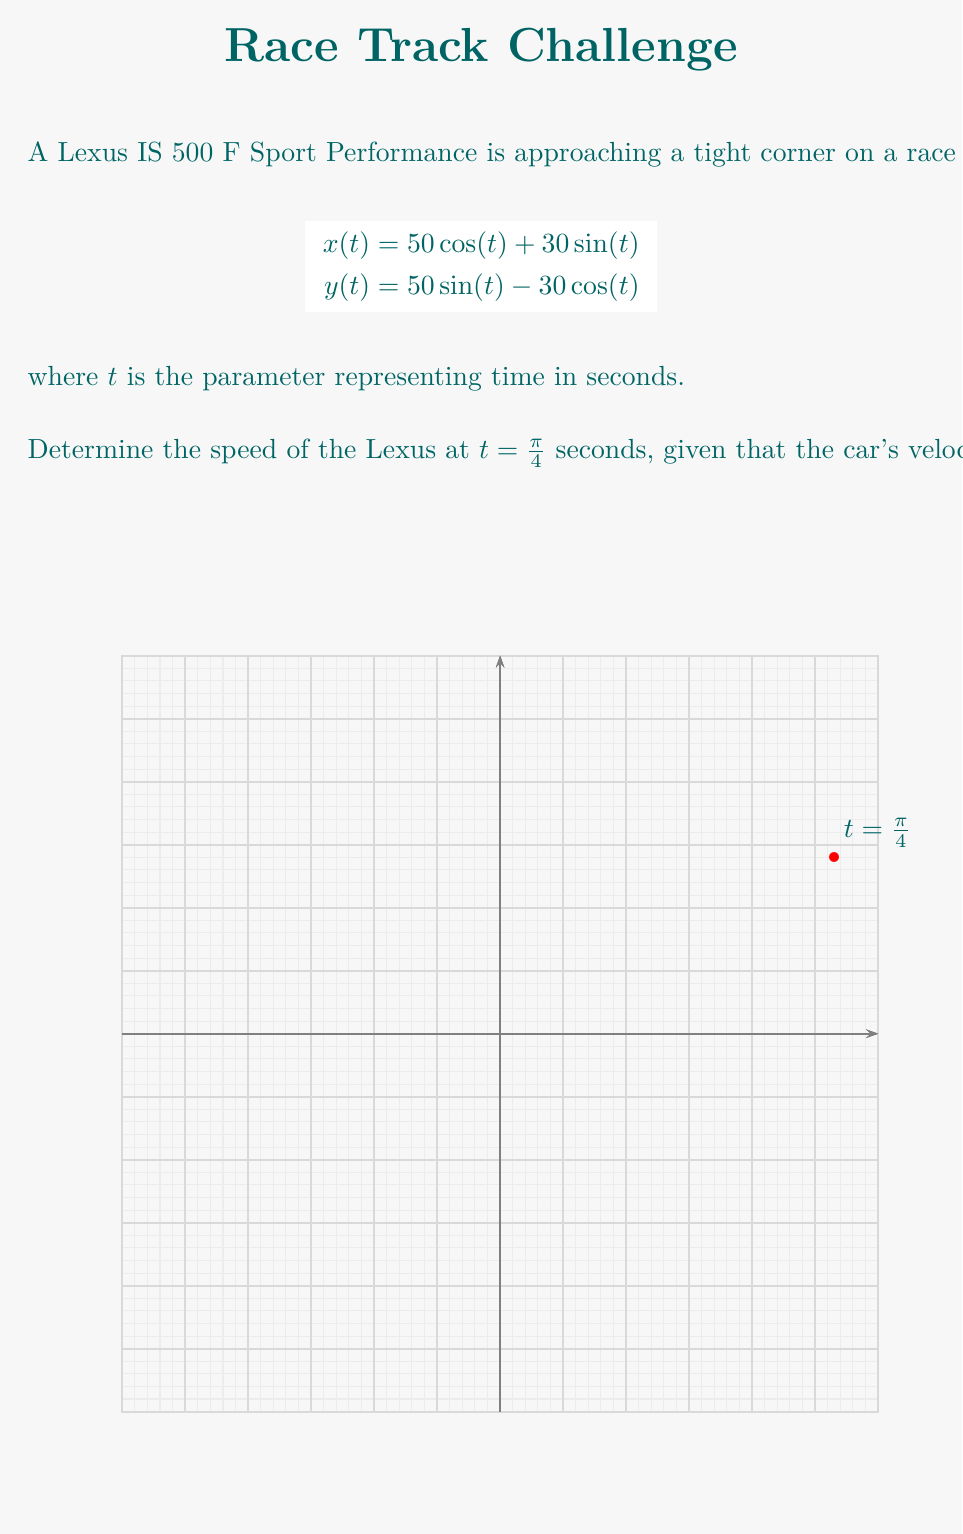Show me your answer to this math problem. To solve this problem, we'll follow these steps:

1) The velocity vector is given by the first derivatives of x and y with respect to t:

   $$\frac{dx}{dt} = -50 \sin(t) + 30 \cos(t)$$
   $$\frac{dy}{dt} = 50 \cos(t) + 30 \sin(t)$$

2) The speed is the magnitude of the velocity vector:

   $$\text{speed} = \sqrt{\left(\frac{dx}{dt}\right)^2 + \left(\frac{dy}{dt}\right)^2}$$

3) Let's substitute $t = \frac{\pi}{4}$ into the derivatives:

   $$\frac{dx}{dt}\bigg|_{t=\frac{\pi}{4}} = -50 \sin(\frac{\pi}{4}) + 30 \cos(\frac{\pi}{4}) = -50 \cdot \frac{\sqrt{2}}{2} + 30 \cdot \frac{\sqrt{2}}{2} = -10\sqrt{2}$$

   $$\frac{dy}{dt}\bigg|_{t=\frac{\pi}{4}} = 50 \cos(\frac{\pi}{4}) + 30 \sin(\frac{\pi}{4}) = 50 \cdot \frac{\sqrt{2}}{2} + 30 \cdot \frac{\sqrt{2}}{2} = 40\sqrt{2}$$

4) Now, we can calculate the speed:

   $$\text{speed} = \sqrt{(-10\sqrt{2})^2 + (40\sqrt{2})^2}$$
   $$= \sqrt{200 + 3200}$$
   $$= \sqrt{3400}$$
   $$\approx 58.31 \text{ m/s}$$

5) Rounding to the nearest whole number:

   Speed ≈ 58 m/s
Answer: 58 m/s 